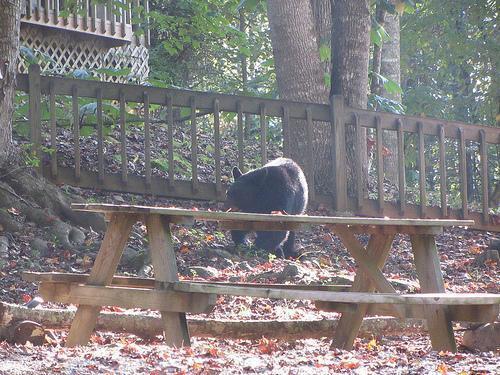How many bears are in this picture?
Give a very brief answer. 1. 